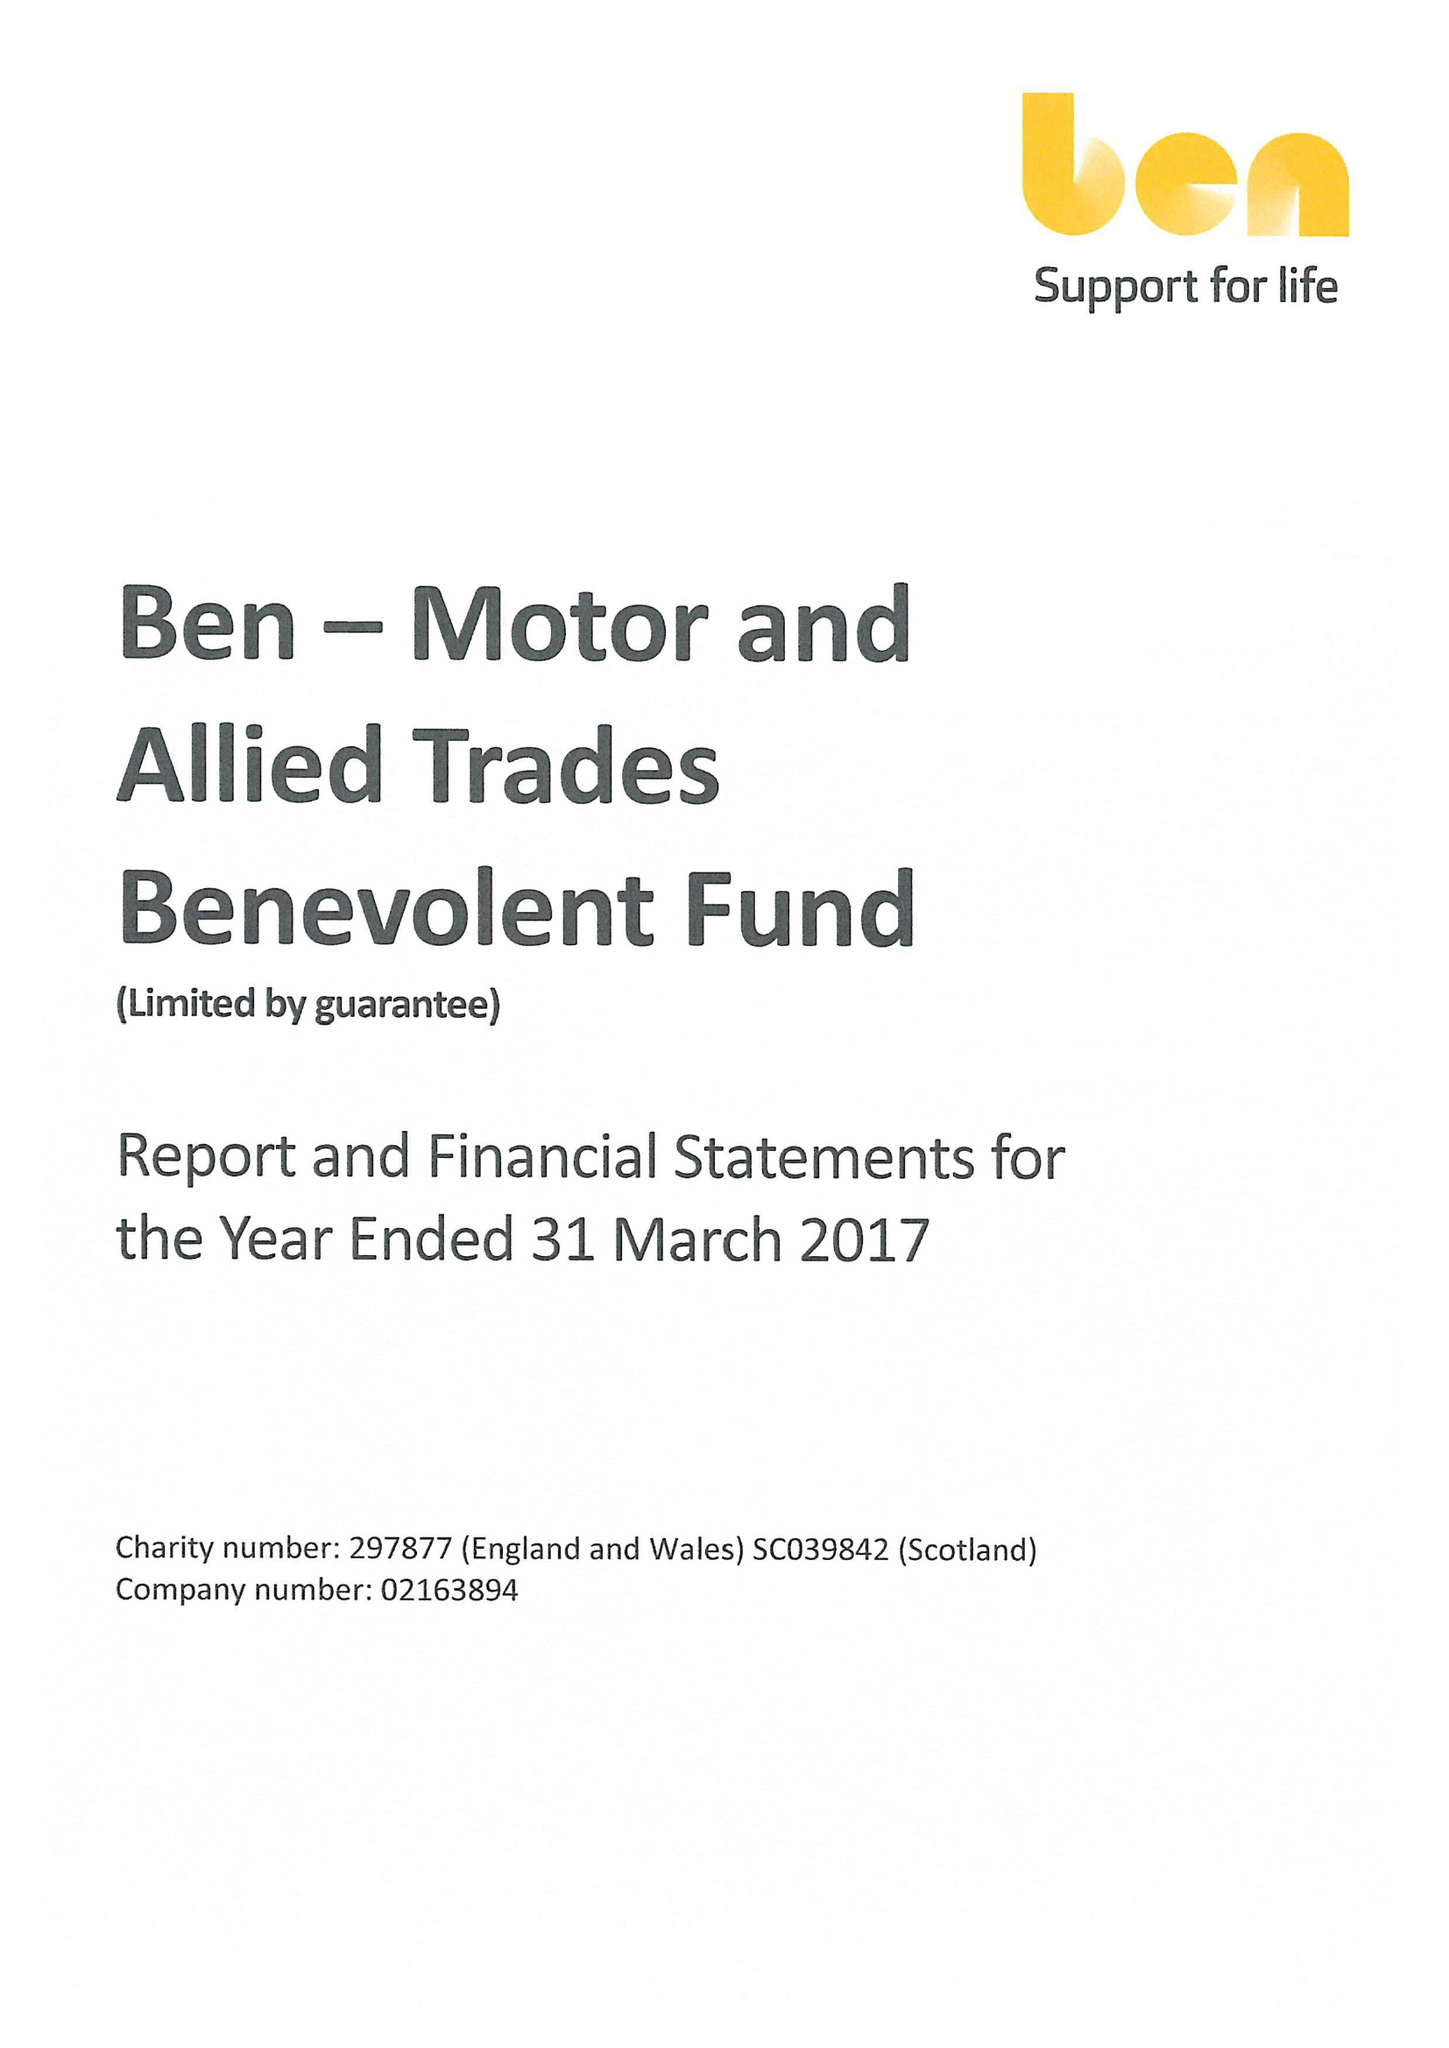What is the value for the address__street_line?
Answer the question using a single word or phrase. RISE ROAD 